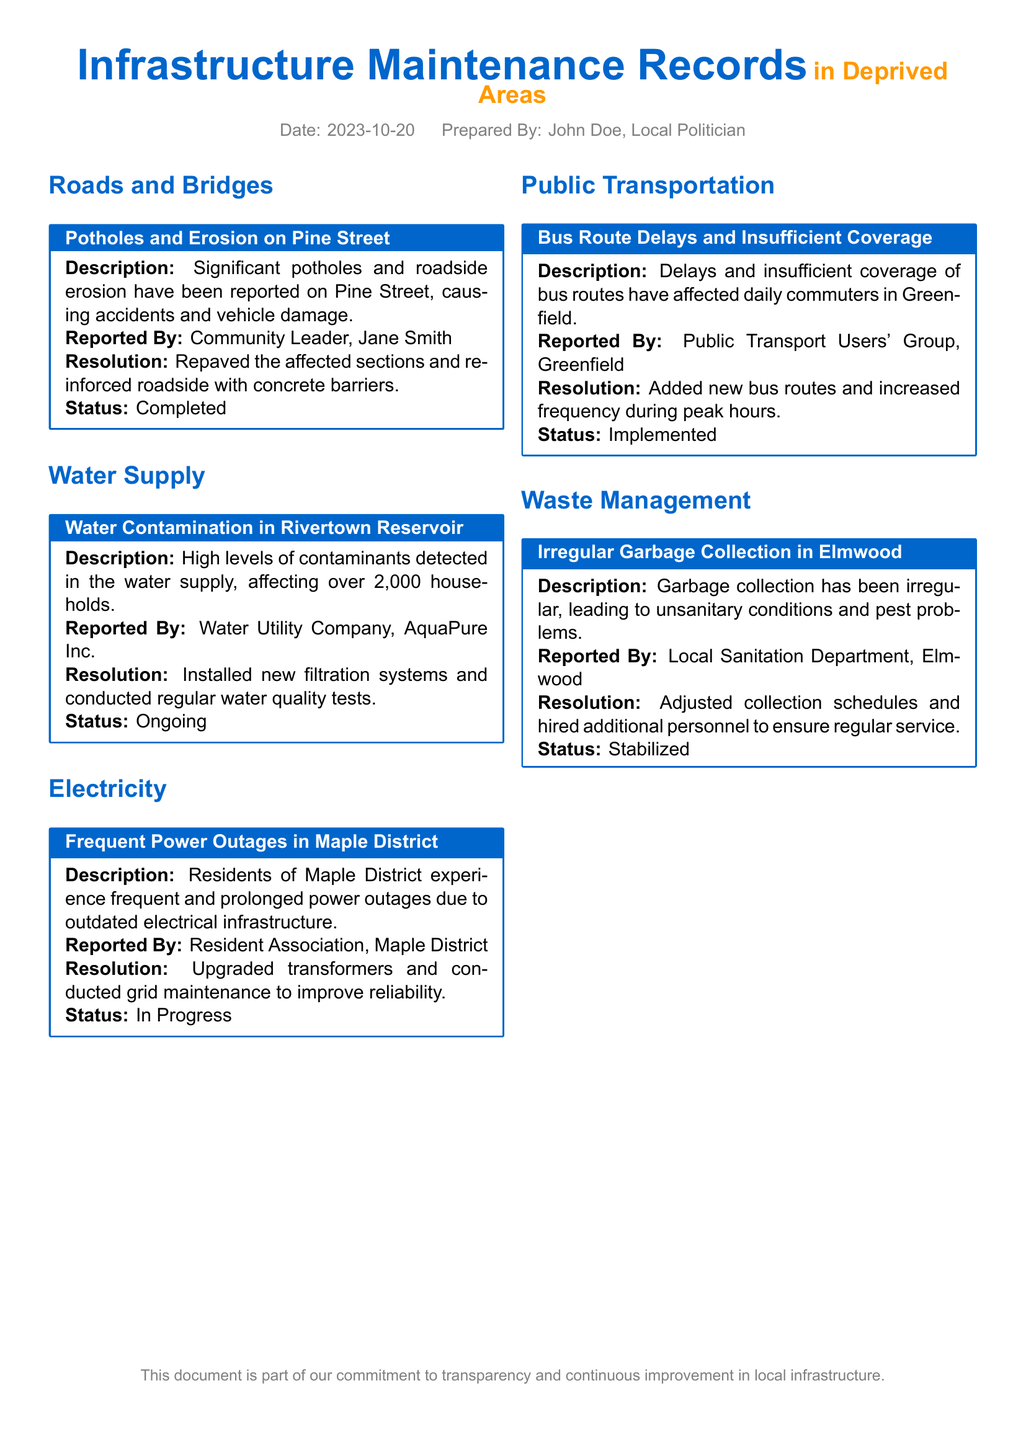What is the date of the report? The date of the report is given at the beginning of the document.
Answer: 2023-10-20 Who reported the potholes on Pine Street? The name of the person who reported the potholes is mentioned in the section about Pine Street.
Answer: Jane Smith What is the status of the water contamination issue? The status of the water contamination issue is specified in the maintenance log.
Answer: Ongoing How many households are affected by the water contamination in Rivertown Reservoir? The document states the number of households affected by the contamination.
Answer: Over 2,000 households What was the resolution for the irregular garbage collection in Elmwood? The resolution for the garbage collection issue is detailed in the waste management section.
Answer: Adjusted collection schedules and hired additional personnel to ensure regular service What improvements were made to the electricity infrastructure in Maple District? The improvements made are described in the electricity section of the document.
Answer: Upgraded transformers and conducted grid maintenance to improve reliability What issue was reported regarding public transportation in Greenfield? The reported issue is indicated in the public transportation section.
Answer: Bus Route Delays and Insufficient Coverage What type of document is this? The structure and content indicate the nature of this document.
Answer: Maintenance log 